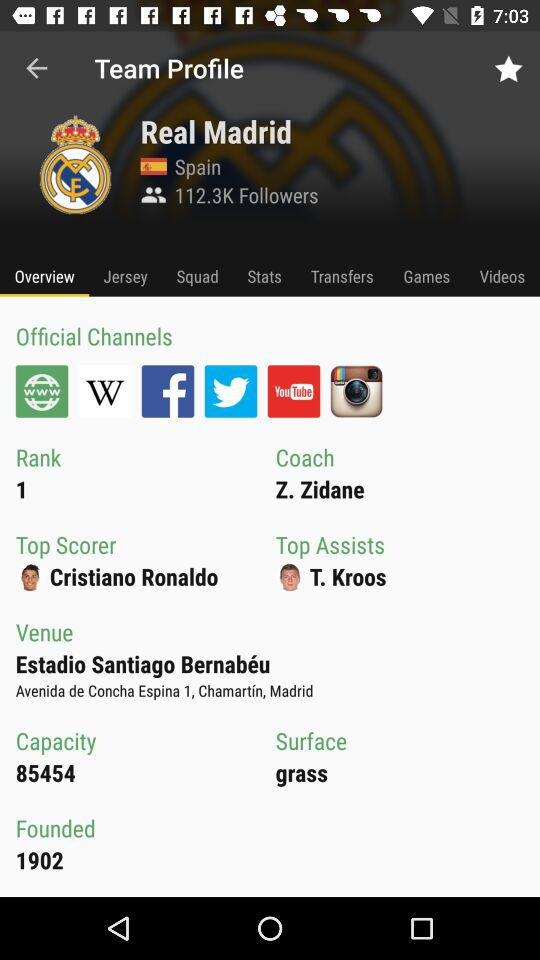Which team profile is currently shown on the screen? The currently shown team profile is "Real Madrid". 